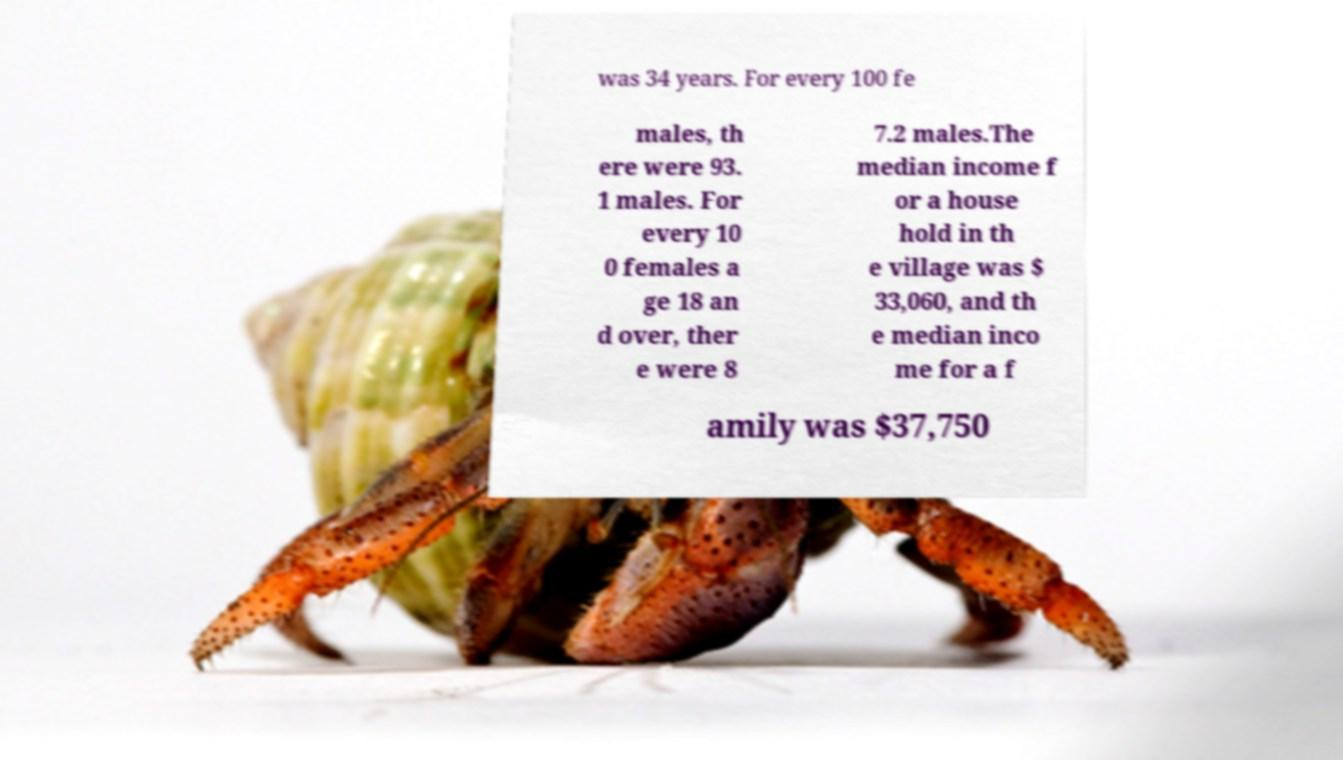Can you read and provide the text displayed in the image?This photo seems to have some interesting text. Can you extract and type it out for me? was 34 years. For every 100 fe males, th ere were 93. 1 males. For every 10 0 females a ge 18 an d over, ther e were 8 7.2 males.The median income f or a house hold in th e village was $ 33,060, and th e median inco me for a f amily was $37,750 